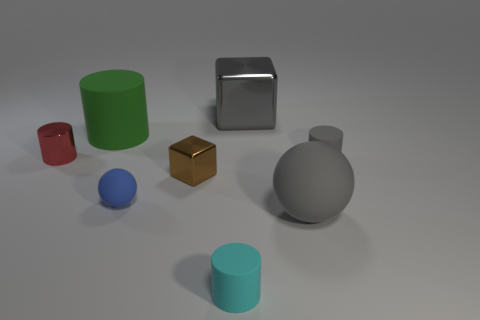There is a block that is in front of the thing that is on the left side of the rubber cylinder to the left of the blue matte object; what is it made of?
Keep it short and to the point. Metal. What number of cubes are large gray matte objects or green things?
Your response must be concise. 0. Are there any other things that are the same size as the green matte cylinder?
Keep it short and to the point. Yes. There is a metal cube left of the block that is to the right of the small block; how many large metal cubes are in front of it?
Give a very brief answer. 0. Is the green matte object the same shape as the tiny blue matte thing?
Provide a short and direct response. No. Do the cube that is on the left side of the large gray block and the cube on the right side of the brown shiny cube have the same material?
Give a very brief answer. Yes. How many things are small cylinders that are left of the tiny blue matte sphere or big things on the right side of the big green matte object?
Your response must be concise. 3. Are there any other things that are the same shape as the small brown object?
Your answer should be compact. Yes. How many large gray shiny objects are there?
Your response must be concise. 1. Are there any other brown blocks of the same size as the brown block?
Give a very brief answer. No. 